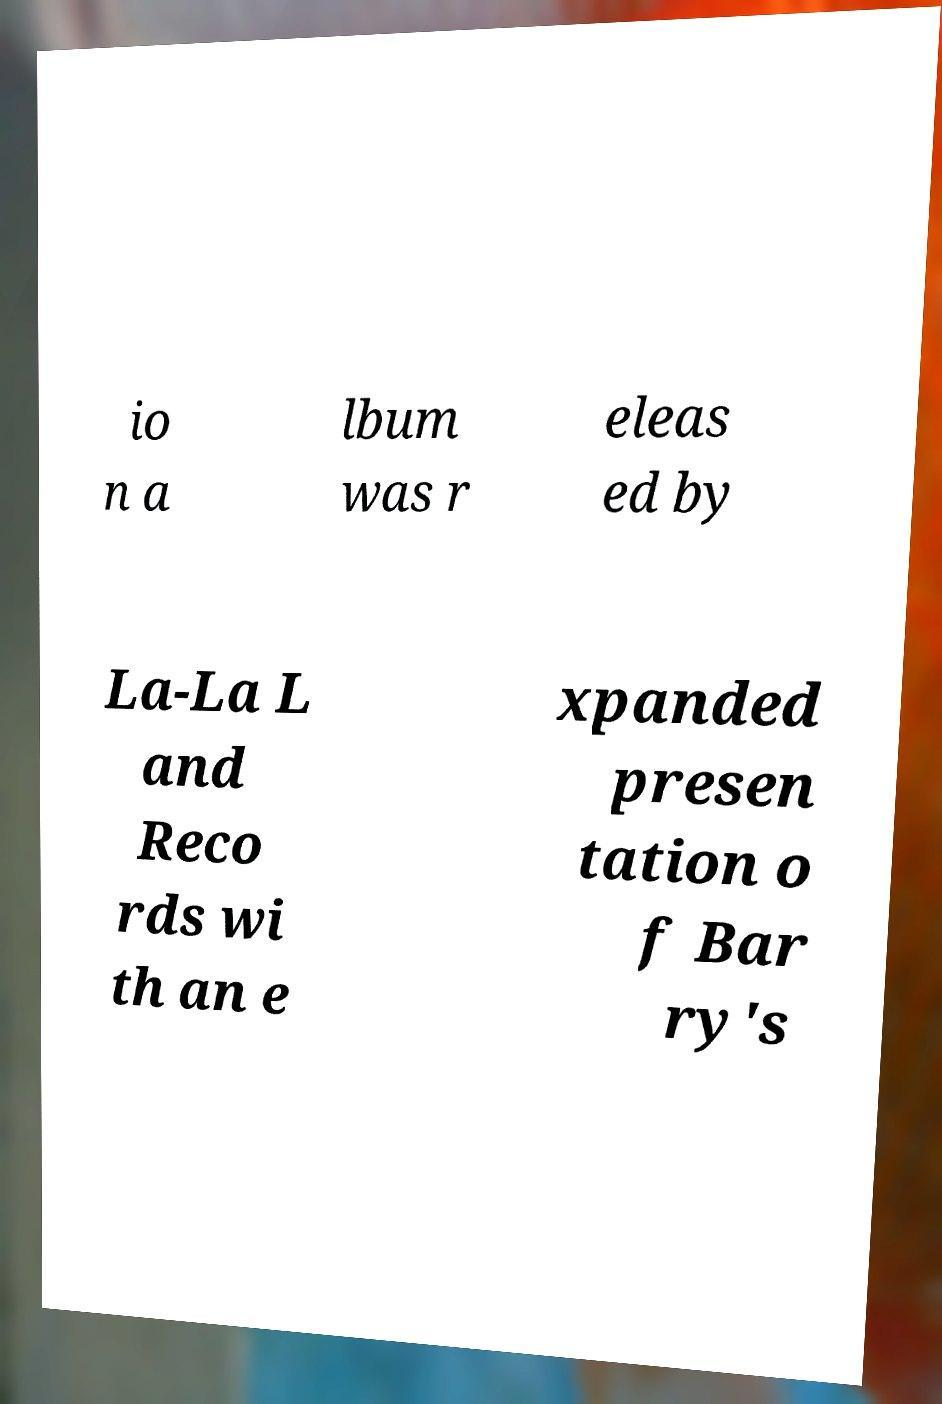Could you assist in decoding the text presented in this image and type it out clearly? io n a lbum was r eleas ed by La-La L and Reco rds wi th an e xpanded presen tation o f Bar ry's 